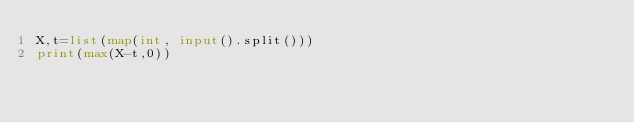<code> <loc_0><loc_0><loc_500><loc_500><_Python_>X,t=list(map(int, input().split()))
print(max(X-t,0))</code> 